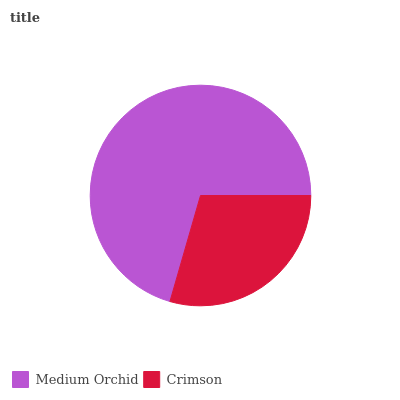Is Crimson the minimum?
Answer yes or no. Yes. Is Medium Orchid the maximum?
Answer yes or no. Yes. Is Crimson the maximum?
Answer yes or no. No. Is Medium Orchid greater than Crimson?
Answer yes or no. Yes. Is Crimson less than Medium Orchid?
Answer yes or no. Yes. Is Crimson greater than Medium Orchid?
Answer yes or no. No. Is Medium Orchid less than Crimson?
Answer yes or no. No. Is Medium Orchid the high median?
Answer yes or no. Yes. Is Crimson the low median?
Answer yes or no. Yes. Is Crimson the high median?
Answer yes or no. No. Is Medium Orchid the low median?
Answer yes or no. No. 